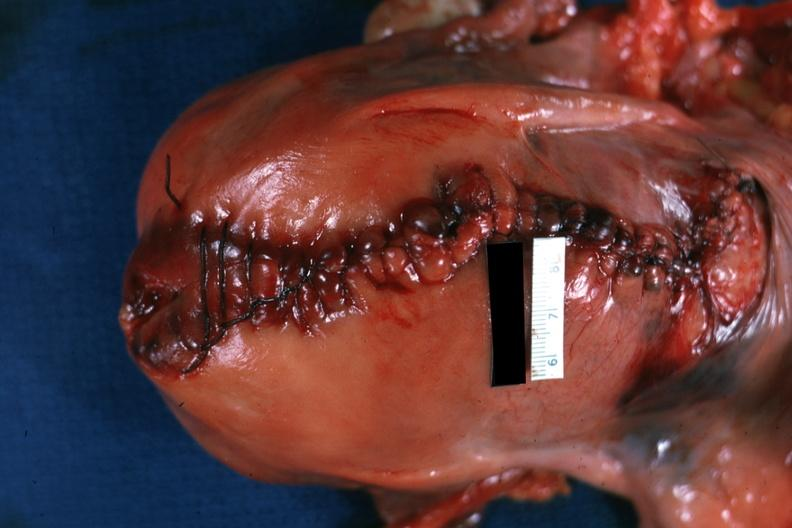does this image show sutured cesarean section incision?
Answer the question using a single word or phrase. Yes 